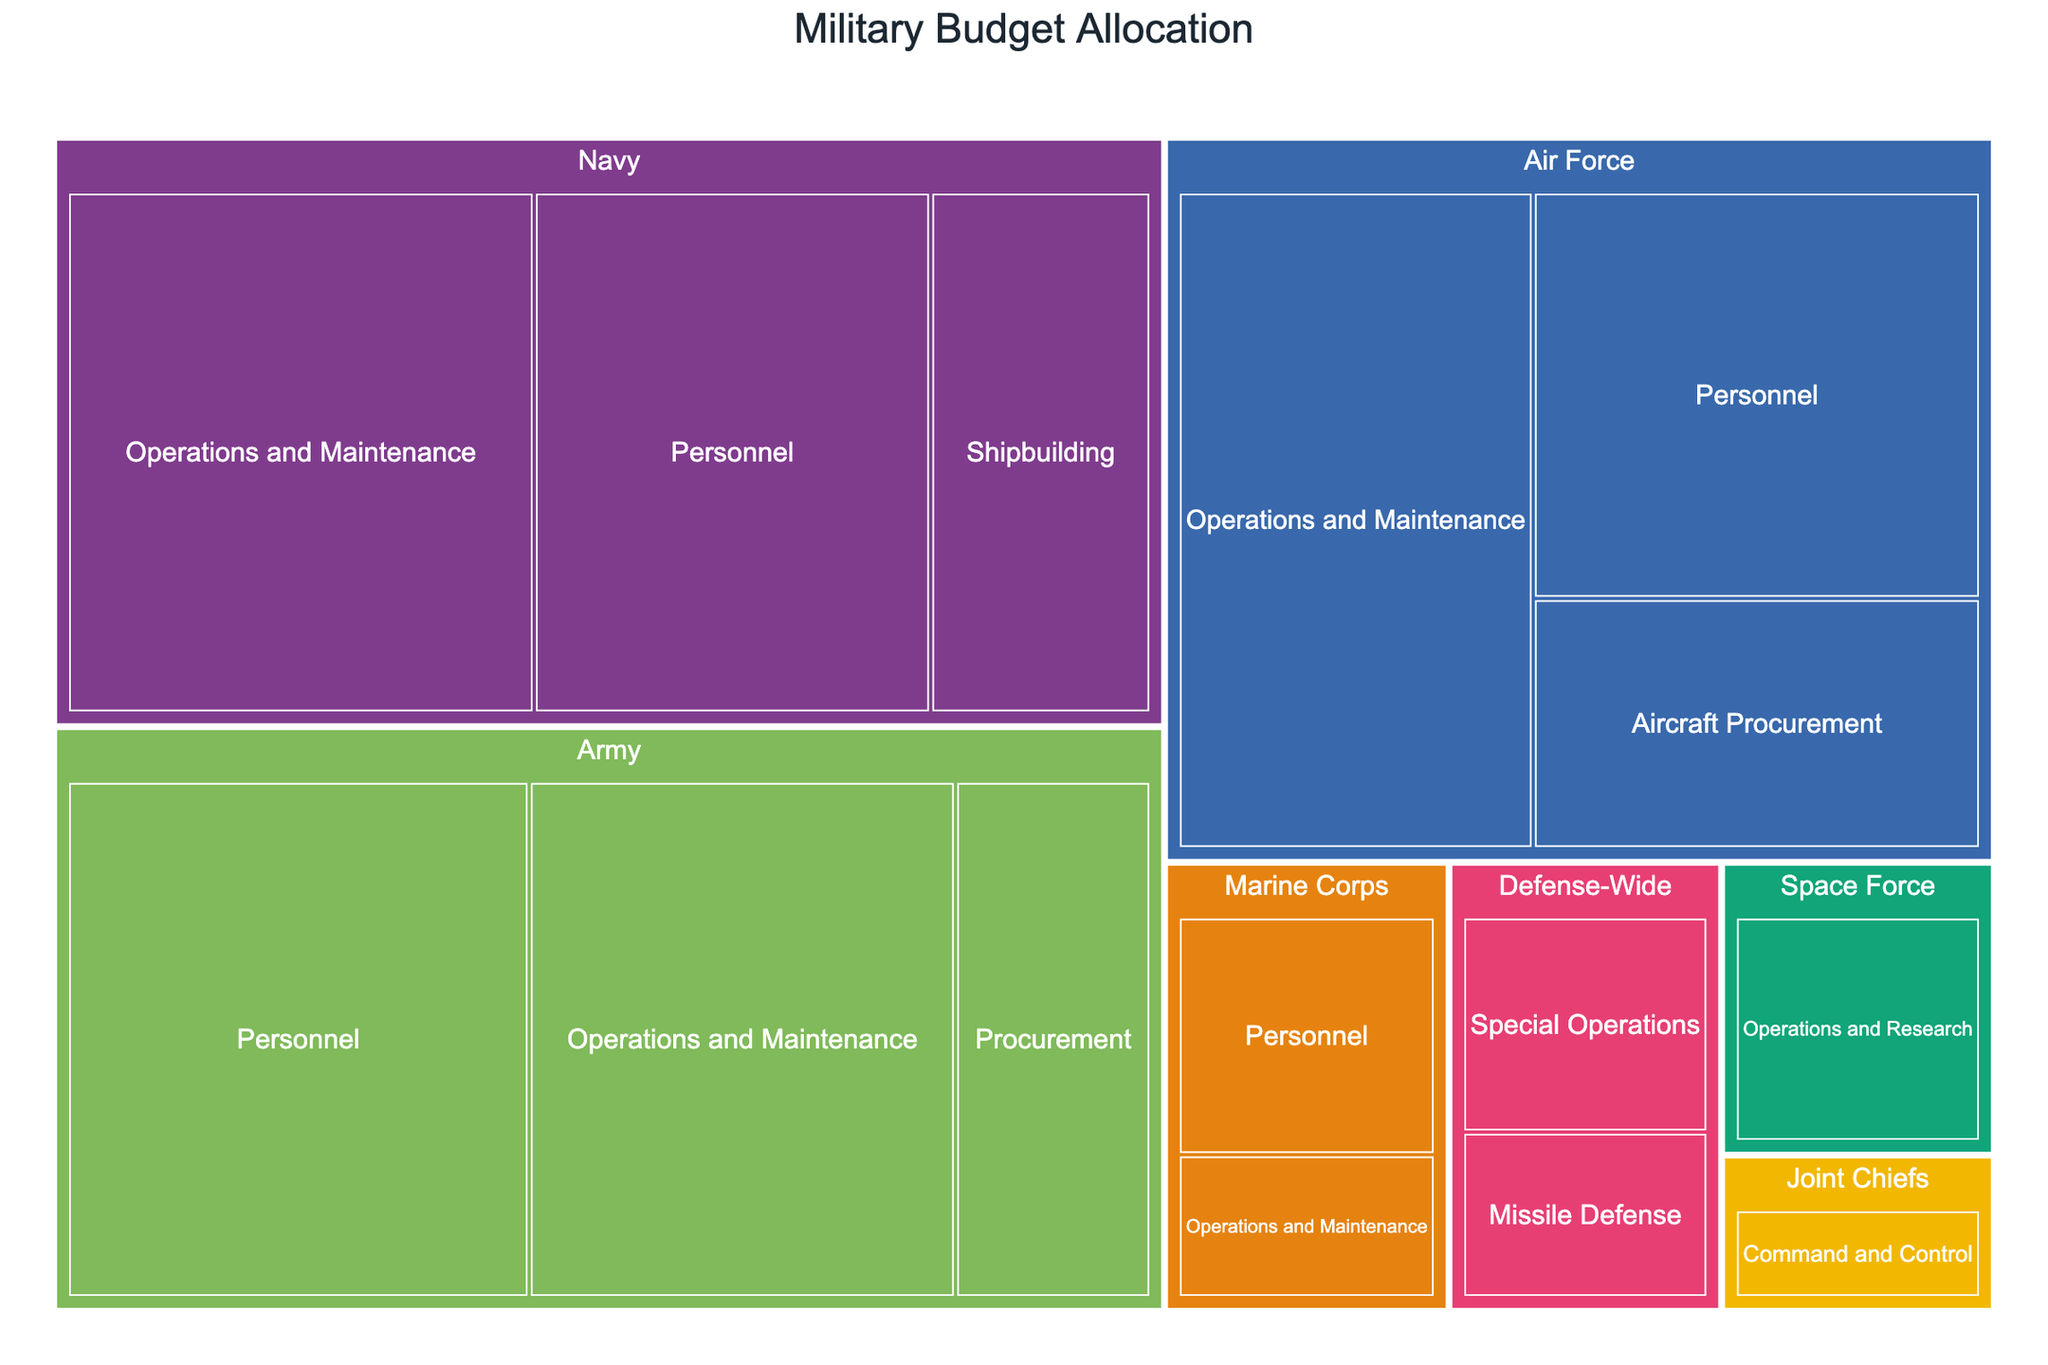What's the title of the treemap? The title of the treemap is displayed at the top center of the figure, written in bold and larger font size.
Answer: Military Budget Allocation Which branch has the largest budget for personnel? Look at the color-coded sections for each branch and identify which Personnel segment is the largest. For Personnel, the Army ($52 billion) is the largest.
Answer: Army How much budget is allocated to the Navy's Operations and Maintenance? Locate the Navy's section of the treemap and find the Operations and Maintenance segment. The budget is displayed as $53 billion.
Answer: $53 billion What is the total budget allocated to the Marine Corps? Sum up the budget allocations for all departments under the Marine Corps. These are Personnel ($15 billion) and Operations and Maintenance ($9 billion). $15 billion + $9 billion = $24 billion.
Answer: $24 billion Which department within the Air Force receives the highest budget? Locate the Air Force section and compare the different department segments. Operations and Maintenance has the highest budget ($50 billion).
Answer: Operations and Maintenance How do the budgets for Army Operations and Maintenance and Navy Shipbuilding compare? Find and compare the size of the respective segments for Army Operations and Maintenance ($48 billion) and Navy Shipbuilding ($25 billion). Army Operations and Maintenance has a higher budget.
Answer: Army Operations and Maintenance Which branch has the smallest budget, and what is that budget? Identify the smallest section among all branches. Space Force has a single section, which amounts to $15 billion, making it the smallest branch budget-wise.
Answer: Space Force, $15 billion What percentage of the total Marine Corps budget is allocated to Operations and Maintenance? First, find the total budget for the Marine Corps ($24 billion). The Operations and Maintenance budget is $9 billion. Calculate the percentage: ($9 billion / $24 billion) * 100% = 37.5%.
Answer: 37.5% How does the budget for Air Force Aircraft Procurement compare to the Navy's Shipbuilding? Compare the sizes and values of the Air Force's Aircraft Procurement ($24 billion) and Navy's Shipbuilding ($25 billion). The Navy's Shipbuilding budget is slightly higher.
Answer: Navy's Shipbuilding Which departments have a budget allocation greater than $40 billion? Identify the segments within all branches and departments with budgets exceeding $40 billion. These are Army Personnel ($52 billion), Army Operations and Maintenance ($48 billion), Navy Operations and Maintenance ($53 billion), Air Force Operations and Maintenance ($50 billion), and Navy Personnel ($45 billion).
Answer: Army Personnel, Army Operations and Maintenance, Navy Operations and Maintenance, Air Force Operations and Maintenance, Navy Personnel 